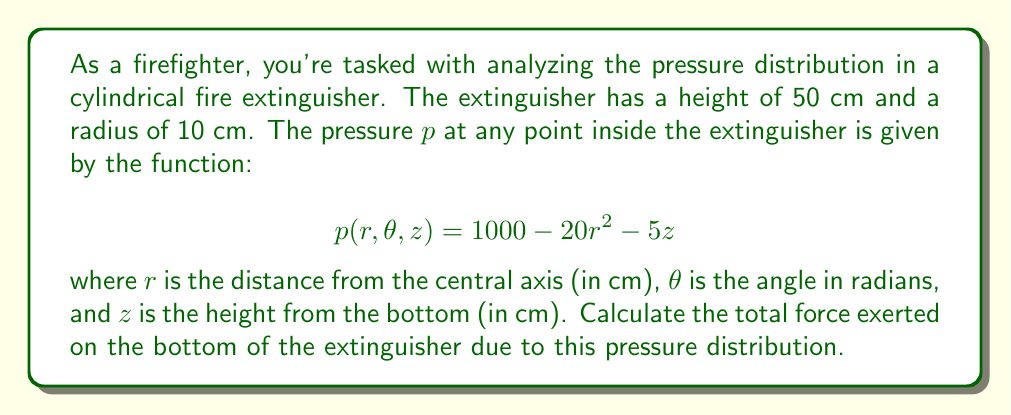Show me your answer to this math problem. To solve this problem, we'll use multivariable calculus, specifically a double integral in polar coordinates. Here's the step-by-step approach:

1) The force on the bottom of the extinguisher is the integral of the pressure over the circular base area. We need to set up a double integral in polar coordinates.

2) The pressure function at the bottom of the extinguisher (z = 0) is:
   $$p(r, \theta, 0) = 1000 - 20r^2$$

3) The force is the integral of pressure over area. In polar coordinates, the area element is $r dr d\theta$. So our integral is:

   $$F = \int_0^{2\pi} \int_0^{10} (1000 - 20r^2) r dr d\theta$$

4) Let's solve the inner integral first:

   $$\int_0^{10} (1000r - 20r^3) dr = [500r^2 - 5r^4]_0^{10}$$
   $$= (50000 - 50000) - (0 - 0) = 0$$

5) Now, the outer integral:

   $$F = \int_0^{2\pi} 0 d\theta = 0 \cdot 2\pi = 0$$

6) To get the force in Newtons, we need to multiply by the conversion factor:
   1 cm^2 * 100 Pa = 1 N

Therefore, the total force on the bottom of the extinguisher is 0 N.

This result might seem counterintuitive, but it's correct. The pressure at the center of the base (r = 0) is higher than at the edges (r = 10), and these differences exactly balance out over the entire base.
Answer: The total force exerted on the bottom of the fire extinguisher is 0 N. 